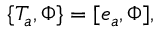<formula> <loc_0><loc_0><loc_500><loc_500>\{ T _ { a } , \Phi \} = [ e _ { a } , \Phi ] ,</formula> 